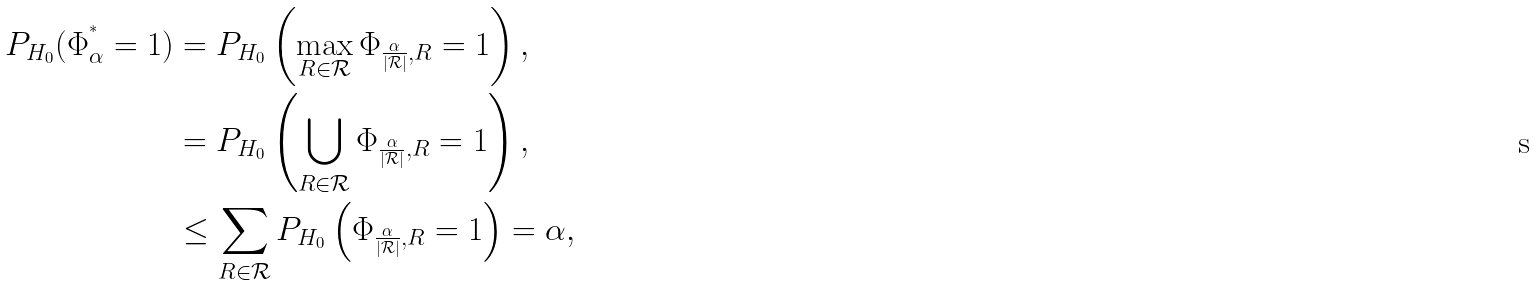Convert formula to latex. <formula><loc_0><loc_0><loc_500><loc_500>P _ { H _ { 0 } } ( \Phi _ { \alpha } ^ { ^ { * } } = 1 ) & = P _ { H _ { 0 } } \left ( \max _ { R \in \mathcal { R } } \Phi _ { \frac { \alpha } { | \mathcal { R } | } , R } = 1 \right ) , \\ & = P _ { H _ { 0 } } \left ( \bigcup _ { R \in \mathcal { R } } \Phi _ { \frac { \alpha } { | \mathcal { R } | } , R } = 1 \right ) , \\ & \leq \sum _ { R \in \mathcal { R } } P _ { H _ { 0 } } \left ( \Phi _ { \frac { \alpha } { | \mathcal { R } | } , R } = 1 \right ) = \alpha ,</formula> 